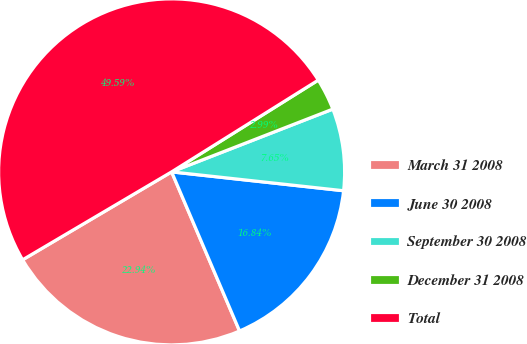<chart> <loc_0><loc_0><loc_500><loc_500><pie_chart><fcel>March 31 2008<fcel>June 30 2008<fcel>September 30 2008<fcel>December 31 2008<fcel>Total<nl><fcel>22.94%<fcel>16.84%<fcel>7.65%<fcel>2.99%<fcel>49.59%<nl></chart> 